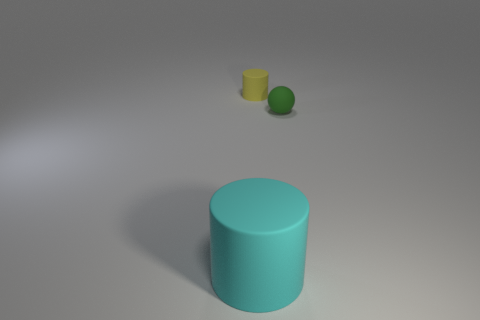Are there any other things that have the same size as the cyan matte cylinder?
Offer a terse response. No. Is the number of yellow matte things behind the cyan rubber thing greater than the number of large cyan matte cylinders that are behind the tiny matte sphere?
Offer a terse response. Yes. What is the color of the other rubber thing that is the same shape as the big cyan matte thing?
Your answer should be compact. Yellow. Are there any other things that are the same shape as the small green object?
Offer a very short reply. No. There is a cyan matte thing; is its shape the same as the tiny matte thing left of the ball?
Make the answer very short. Yes. What number of other objects are the same material as the tiny green sphere?
Offer a very short reply. 2. Is the color of the large cylinder the same as the small matte object to the left of the small green thing?
Make the answer very short. No. What is the object that is right of the yellow cylinder made of?
Make the answer very short. Rubber. Is there another rubber cylinder that has the same color as the large matte cylinder?
Your answer should be very brief. No. There is a rubber sphere that is the same size as the yellow rubber cylinder; what is its color?
Your answer should be compact. Green. 